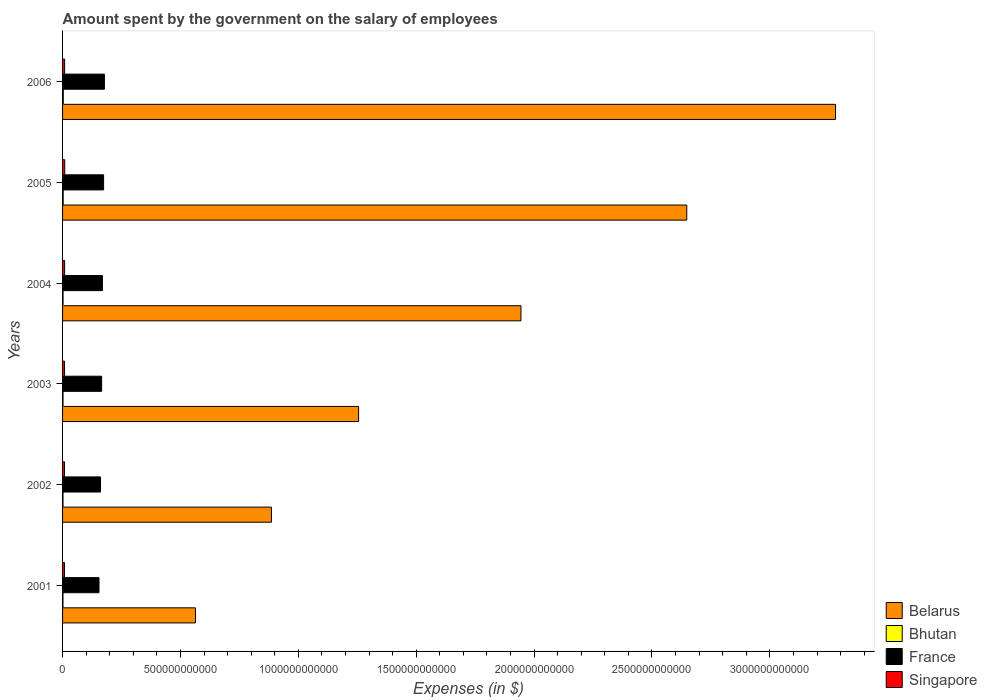How many different coloured bars are there?
Your response must be concise. 4. How many groups of bars are there?
Give a very brief answer. 6. Are the number of bars on each tick of the Y-axis equal?
Ensure brevity in your answer.  Yes. What is the label of the 3rd group of bars from the top?
Your response must be concise. 2004. In how many cases, is the number of bars for a given year not equal to the number of legend labels?
Offer a very short reply. 0. What is the amount spent on the salary of employees by the government in Bhutan in 2006?
Your answer should be compact. 3.09e+09. Across all years, what is the maximum amount spent on the salary of employees by the government in France?
Provide a short and direct response. 1.78e+11. Across all years, what is the minimum amount spent on the salary of employees by the government in Singapore?
Your response must be concise. 8.00e+09. In which year was the amount spent on the salary of employees by the government in France maximum?
Offer a terse response. 2006. What is the total amount spent on the salary of employees by the government in Singapore in the graph?
Offer a terse response. 5.11e+1. What is the difference between the amount spent on the salary of employees by the government in Belarus in 2002 and that in 2005?
Ensure brevity in your answer.  -1.76e+12. What is the difference between the amount spent on the salary of employees by the government in Belarus in 2004 and the amount spent on the salary of employees by the government in Bhutan in 2006?
Give a very brief answer. 1.94e+12. What is the average amount spent on the salary of employees by the government in Belarus per year?
Offer a very short reply. 1.76e+12. In the year 2003, what is the difference between the amount spent on the salary of employees by the government in Bhutan and amount spent on the salary of employees by the government in Singapore?
Your answer should be compact. -6.36e+09. In how many years, is the amount spent on the salary of employees by the government in Belarus greater than 800000000000 $?
Ensure brevity in your answer.  5. What is the ratio of the amount spent on the salary of employees by the government in France in 2004 to that in 2006?
Offer a very short reply. 0.95. Is the amount spent on the salary of employees by the government in France in 2003 less than that in 2004?
Offer a terse response. Yes. What is the difference between the highest and the second highest amount spent on the salary of employees by the government in Singapore?
Offer a terse response. 3.91e+08. What is the difference between the highest and the lowest amount spent on the salary of employees by the government in Bhutan?
Your answer should be very brief. 1.37e+09. In how many years, is the amount spent on the salary of employees by the government in Belarus greater than the average amount spent on the salary of employees by the government in Belarus taken over all years?
Your response must be concise. 3. Is the sum of the amount spent on the salary of employees by the government in France in 2002 and 2006 greater than the maximum amount spent on the salary of employees by the government in Bhutan across all years?
Provide a succinct answer. Yes. Is it the case that in every year, the sum of the amount spent on the salary of employees by the government in Belarus and amount spent on the salary of employees by the government in France is greater than the sum of amount spent on the salary of employees by the government in Bhutan and amount spent on the salary of employees by the government in Singapore?
Offer a very short reply. Yes. What does the 3rd bar from the top in 2003 represents?
Make the answer very short. Bhutan. What does the 1st bar from the bottom in 2002 represents?
Offer a very short reply. Belarus. Is it the case that in every year, the sum of the amount spent on the salary of employees by the government in Belarus and amount spent on the salary of employees by the government in France is greater than the amount spent on the salary of employees by the government in Singapore?
Your answer should be compact. Yes. How many bars are there?
Ensure brevity in your answer.  24. Are all the bars in the graph horizontal?
Make the answer very short. Yes. What is the difference between two consecutive major ticks on the X-axis?
Offer a very short reply. 5.00e+11. Does the graph contain any zero values?
Your response must be concise. No. What is the title of the graph?
Keep it short and to the point. Amount spent by the government on the salary of employees. Does "East Asia (developing only)" appear as one of the legend labels in the graph?
Give a very brief answer. No. What is the label or title of the X-axis?
Offer a very short reply. Expenses (in $). What is the label or title of the Y-axis?
Ensure brevity in your answer.  Years. What is the Expenses (in $) of Belarus in 2001?
Offer a terse response. 5.64e+11. What is the Expenses (in $) in Bhutan in 2001?
Provide a succinct answer. 1.72e+09. What is the Expenses (in $) of France in 2001?
Ensure brevity in your answer.  1.55e+11. What is the Expenses (in $) of Singapore in 2001?
Your answer should be compact. 8.00e+09. What is the Expenses (in $) of Belarus in 2002?
Your answer should be very brief. 8.86e+11. What is the Expenses (in $) in Bhutan in 2002?
Keep it short and to the point. 1.90e+09. What is the Expenses (in $) in France in 2002?
Keep it short and to the point. 1.61e+11. What is the Expenses (in $) in Singapore in 2002?
Provide a succinct answer. 8.28e+09. What is the Expenses (in $) in Belarus in 2003?
Provide a short and direct response. 1.26e+12. What is the Expenses (in $) in Bhutan in 2003?
Keep it short and to the point. 1.95e+09. What is the Expenses (in $) in France in 2003?
Ensure brevity in your answer.  1.66e+11. What is the Expenses (in $) of Singapore in 2003?
Your answer should be very brief. 8.31e+09. What is the Expenses (in $) of Belarus in 2004?
Give a very brief answer. 1.94e+12. What is the Expenses (in $) in Bhutan in 2004?
Provide a succinct answer. 2.09e+09. What is the Expenses (in $) in France in 2004?
Offer a very short reply. 1.69e+11. What is the Expenses (in $) in Singapore in 2004?
Provide a short and direct response. 8.71e+09. What is the Expenses (in $) of Belarus in 2005?
Provide a short and direct response. 2.65e+12. What is the Expenses (in $) of Bhutan in 2005?
Your answer should be compact. 2.65e+09. What is the Expenses (in $) in France in 2005?
Your response must be concise. 1.74e+11. What is the Expenses (in $) of Singapore in 2005?
Provide a short and direct response. 9.11e+09. What is the Expenses (in $) of Belarus in 2006?
Offer a terse response. 3.28e+12. What is the Expenses (in $) in Bhutan in 2006?
Your response must be concise. 3.09e+09. What is the Expenses (in $) in France in 2006?
Your answer should be very brief. 1.78e+11. What is the Expenses (in $) in Singapore in 2006?
Give a very brief answer. 8.72e+09. Across all years, what is the maximum Expenses (in $) in Belarus?
Your answer should be very brief. 3.28e+12. Across all years, what is the maximum Expenses (in $) in Bhutan?
Keep it short and to the point. 3.09e+09. Across all years, what is the maximum Expenses (in $) of France?
Keep it short and to the point. 1.78e+11. Across all years, what is the maximum Expenses (in $) of Singapore?
Your answer should be very brief. 9.11e+09. Across all years, what is the minimum Expenses (in $) of Belarus?
Your response must be concise. 5.64e+11. Across all years, what is the minimum Expenses (in $) in Bhutan?
Your response must be concise. 1.72e+09. Across all years, what is the minimum Expenses (in $) of France?
Offer a very short reply. 1.55e+11. Across all years, what is the minimum Expenses (in $) of Singapore?
Provide a succinct answer. 8.00e+09. What is the total Expenses (in $) of Belarus in the graph?
Make the answer very short. 1.06e+13. What is the total Expenses (in $) of Bhutan in the graph?
Make the answer very short. 1.34e+1. What is the total Expenses (in $) in France in the graph?
Give a very brief answer. 1.00e+12. What is the total Expenses (in $) of Singapore in the graph?
Provide a succinct answer. 5.11e+1. What is the difference between the Expenses (in $) in Belarus in 2001 and that in 2002?
Provide a short and direct response. -3.22e+11. What is the difference between the Expenses (in $) in Bhutan in 2001 and that in 2002?
Your response must be concise. -1.74e+08. What is the difference between the Expenses (in $) in France in 2001 and that in 2002?
Your answer should be compact. -6.46e+09. What is the difference between the Expenses (in $) in Singapore in 2001 and that in 2002?
Your answer should be very brief. -2.80e+08. What is the difference between the Expenses (in $) of Belarus in 2001 and that in 2003?
Keep it short and to the point. -6.92e+11. What is the difference between the Expenses (in $) of Bhutan in 2001 and that in 2003?
Your response must be concise. -2.24e+08. What is the difference between the Expenses (in $) in France in 2001 and that in 2003?
Your answer should be compact. -1.11e+1. What is the difference between the Expenses (in $) in Singapore in 2001 and that in 2003?
Keep it short and to the point. -3.03e+08. What is the difference between the Expenses (in $) in Belarus in 2001 and that in 2004?
Your answer should be very brief. -1.38e+12. What is the difference between the Expenses (in $) in Bhutan in 2001 and that in 2004?
Give a very brief answer. -3.64e+08. What is the difference between the Expenses (in $) of France in 2001 and that in 2004?
Your answer should be compact. -1.45e+1. What is the difference between the Expenses (in $) of Singapore in 2001 and that in 2004?
Offer a terse response. -7.03e+08. What is the difference between the Expenses (in $) in Belarus in 2001 and that in 2005?
Keep it short and to the point. -2.08e+12. What is the difference between the Expenses (in $) of Bhutan in 2001 and that in 2005?
Offer a terse response. -9.29e+08. What is the difference between the Expenses (in $) in France in 2001 and that in 2005?
Ensure brevity in your answer.  -1.95e+1. What is the difference between the Expenses (in $) of Singapore in 2001 and that in 2005?
Offer a very short reply. -1.11e+09. What is the difference between the Expenses (in $) in Belarus in 2001 and that in 2006?
Your response must be concise. -2.72e+12. What is the difference between the Expenses (in $) in Bhutan in 2001 and that in 2006?
Provide a succinct answer. -1.37e+09. What is the difference between the Expenses (in $) of France in 2001 and that in 2006?
Your answer should be compact. -2.30e+1. What is the difference between the Expenses (in $) of Singapore in 2001 and that in 2006?
Provide a short and direct response. -7.16e+08. What is the difference between the Expenses (in $) of Belarus in 2002 and that in 2003?
Keep it short and to the point. -3.70e+11. What is the difference between the Expenses (in $) in Bhutan in 2002 and that in 2003?
Offer a terse response. -4.99e+07. What is the difference between the Expenses (in $) of France in 2002 and that in 2003?
Keep it short and to the point. -4.66e+09. What is the difference between the Expenses (in $) in Singapore in 2002 and that in 2003?
Your answer should be compact. -2.30e+07. What is the difference between the Expenses (in $) of Belarus in 2002 and that in 2004?
Offer a terse response. -1.06e+12. What is the difference between the Expenses (in $) in Bhutan in 2002 and that in 2004?
Your answer should be very brief. -1.90e+08. What is the difference between the Expenses (in $) in France in 2002 and that in 2004?
Keep it short and to the point. -8.00e+09. What is the difference between the Expenses (in $) in Singapore in 2002 and that in 2004?
Your answer should be very brief. -4.23e+08. What is the difference between the Expenses (in $) of Belarus in 2002 and that in 2005?
Ensure brevity in your answer.  -1.76e+12. What is the difference between the Expenses (in $) in Bhutan in 2002 and that in 2005?
Offer a very short reply. -7.55e+08. What is the difference between the Expenses (in $) of France in 2002 and that in 2005?
Offer a very short reply. -1.31e+1. What is the difference between the Expenses (in $) of Singapore in 2002 and that in 2005?
Your answer should be compact. -8.27e+08. What is the difference between the Expenses (in $) of Belarus in 2002 and that in 2006?
Make the answer very short. -2.39e+12. What is the difference between the Expenses (in $) in Bhutan in 2002 and that in 2006?
Your response must be concise. -1.20e+09. What is the difference between the Expenses (in $) of France in 2002 and that in 2006?
Keep it short and to the point. -1.65e+1. What is the difference between the Expenses (in $) of Singapore in 2002 and that in 2006?
Your answer should be compact. -4.36e+08. What is the difference between the Expenses (in $) of Belarus in 2003 and that in 2004?
Your answer should be compact. -6.89e+11. What is the difference between the Expenses (in $) of Bhutan in 2003 and that in 2004?
Offer a very short reply. -1.40e+08. What is the difference between the Expenses (in $) in France in 2003 and that in 2004?
Provide a succinct answer. -3.34e+09. What is the difference between the Expenses (in $) in Singapore in 2003 and that in 2004?
Make the answer very short. -4.00e+08. What is the difference between the Expenses (in $) of Belarus in 2003 and that in 2005?
Provide a succinct answer. -1.39e+12. What is the difference between the Expenses (in $) of Bhutan in 2003 and that in 2005?
Make the answer very short. -7.05e+08. What is the difference between the Expenses (in $) of France in 2003 and that in 2005?
Give a very brief answer. -8.40e+09. What is the difference between the Expenses (in $) in Singapore in 2003 and that in 2005?
Your answer should be very brief. -8.04e+08. What is the difference between the Expenses (in $) of Belarus in 2003 and that in 2006?
Make the answer very short. -2.02e+12. What is the difference between the Expenses (in $) of Bhutan in 2003 and that in 2006?
Provide a succinct answer. -1.15e+09. What is the difference between the Expenses (in $) in France in 2003 and that in 2006?
Your answer should be compact. -1.19e+1. What is the difference between the Expenses (in $) of Singapore in 2003 and that in 2006?
Provide a short and direct response. -4.13e+08. What is the difference between the Expenses (in $) in Belarus in 2004 and that in 2005?
Your answer should be very brief. -7.03e+11. What is the difference between the Expenses (in $) in Bhutan in 2004 and that in 2005?
Provide a succinct answer. -5.66e+08. What is the difference between the Expenses (in $) of France in 2004 and that in 2005?
Your answer should be compact. -5.05e+09. What is the difference between the Expenses (in $) of Singapore in 2004 and that in 2005?
Ensure brevity in your answer.  -4.04e+08. What is the difference between the Expenses (in $) of Belarus in 2004 and that in 2006?
Give a very brief answer. -1.33e+12. What is the difference between the Expenses (in $) in Bhutan in 2004 and that in 2006?
Give a very brief answer. -1.01e+09. What is the difference between the Expenses (in $) in France in 2004 and that in 2006?
Your answer should be very brief. -8.55e+09. What is the difference between the Expenses (in $) of Singapore in 2004 and that in 2006?
Your response must be concise. -1.30e+07. What is the difference between the Expenses (in $) of Belarus in 2005 and that in 2006?
Provide a short and direct response. -6.31e+11. What is the difference between the Expenses (in $) in Bhutan in 2005 and that in 2006?
Offer a terse response. -4.40e+08. What is the difference between the Expenses (in $) of France in 2005 and that in 2006?
Your answer should be very brief. -3.49e+09. What is the difference between the Expenses (in $) in Singapore in 2005 and that in 2006?
Ensure brevity in your answer.  3.91e+08. What is the difference between the Expenses (in $) in Belarus in 2001 and the Expenses (in $) in Bhutan in 2002?
Ensure brevity in your answer.  5.62e+11. What is the difference between the Expenses (in $) in Belarus in 2001 and the Expenses (in $) in France in 2002?
Provide a succinct answer. 4.03e+11. What is the difference between the Expenses (in $) in Belarus in 2001 and the Expenses (in $) in Singapore in 2002?
Your answer should be very brief. 5.55e+11. What is the difference between the Expenses (in $) in Bhutan in 2001 and the Expenses (in $) in France in 2002?
Ensure brevity in your answer.  -1.59e+11. What is the difference between the Expenses (in $) in Bhutan in 2001 and the Expenses (in $) in Singapore in 2002?
Offer a terse response. -6.56e+09. What is the difference between the Expenses (in $) in France in 2001 and the Expenses (in $) in Singapore in 2002?
Give a very brief answer. 1.46e+11. What is the difference between the Expenses (in $) in Belarus in 2001 and the Expenses (in $) in Bhutan in 2003?
Offer a terse response. 5.62e+11. What is the difference between the Expenses (in $) of Belarus in 2001 and the Expenses (in $) of France in 2003?
Provide a short and direct response. 3.98e+11. What is the difference between the Expenses (in $) in Belarus in 2001 and the Expenses (in $) in Singapore in 2003?
Offer a terse response. 5.55e+11. What is the difference between the Expenses (in $) in Bhutan in 2001 and the Expenses (in $) in France in 2003?
Your response must be concise. -1.64e+11. What is the difference between the Expenses (in $) in Bhutan in 2001 and the Expenses (in $) in Singapore in 2003?
Your response must be concise. -6.58e+09. What is the difference between the Expenses (in $) of France in 2001 and the Expenses (in $) of Singapore in 2003?
Your answer should be compact. 1.46e+11. What is the difference between the Expenses (in $) in Belarus in 2001 and the Expenses (in $) in Bhutan in 2004?
Provide a succinct answer. 5.62e+11. What is the difference between the Expenses (in $) in Belarus in 2001 and the Expenses (in $) in France in 2004?
Give a very brief answer. 3.95e+11. What is the difference between the Expenses (in $) in Belarus in 2001 and the Expenses (in $) in Singapore in 2004?
Ensure brevity in your answer.  5.55e+11. What is the difference between the Expenses (in $) in Bhutan in 2001 and the Expenses (in $) in France in 2004?
Make the answer very short. -1.67e+11. What is the difference between the Expenses (in $) in Bhutan in 2001 and the Expenses (in $) in Singapore in 2004?
Provide a short and direct response. -6.98e+09. What is the difference between the Expenses (in $) in France in 2001 and the Expenses (in $) in Singapore in 2004?
Give a very brief answer. 1.46e+11. What is the difference between the Expenses (in $) of Belarus in 2001 and the Expenses (in $) of Bhutan in 2005?
Your response must be concise. 5.61e+11. What is the difference between the Expenses (in $) of Belarus in 2001 and the Expenses (in $) of France in 2005?
Provide a short and direct response. 3.90e+11. What is the difference between the Expenses (in $) in Belarus in 2001 and the Expenses (in $) in Singapore in 2005?
Make the answer very short. 5.55e+11. What is the difference between the Expenses (in $) in Bhutan in 2001 and the Expenses (in $) in France in 2005?
Provide a short and direct response. -1.72e+11. What is the difference between the Expenses (in $) in Bhutan in 2001 and the Expenses (in $) in Singapore in 2005?
Provide a short and direct response. -7.39e+09. What is the difference between the Expenses (in $) of France in 2001 and the Expenses (in $) of Singapore in 2005?
Your answer should be compact. 1.45e+11. What is the difference between the Expenses (in $) of Belarus in 2001 and the Expenses (in $) of Bhutan in 2006?
Give a very brief answer. 5.61e+11. What is the difference between the Expenses (in $) in Belarus in 2001 and the Expenses (in $) in France in 2006?
Provide a short and direct response. 3.86e+11. What is the difference between the Expenses (in $) of Belarus in 2001 and the Expenses (in $) of Singapore in 2006?
Give a very brief answer. 5.55e+11. What is the difference between the Expenses (in $) of Bhutan in 2001 and the Expenses (in $) of France in 2006?
Provide a short and direct response. -1.76e+11. What is the difference between the Expenses (in $) of Bhutan in 2001 and the Expenses (in $) of Singapore in 2006?
Your answer should be compact. -7.00e+09. What is the difference between the Expenses (in $) of France in 2001 and the Expenses (in $) of Singapore in 2006?
Ensure brevity in your answer.  1.46e+11. What is the difference between the Expenses (in $) of Belarus in 2002 and the Expenses (in $) of Bhutan in 2003?
Your response must be concise. 8.84e+11. What is the difference between the Expenses (in $) in Belarus in 2002 and the Expenses (in $) in France in 2003?
Offer a terse response. 7.20e+11. What is the difference between the Expenses (in $) in Belarus in 2002 and the Expenses (in $) in Singapore in 2003?
Your answer should be very brief. 8.78e+11. What is the difference between the Expenses (in $) in Bhutan in 2002 and the Expenses (in $) in France in 2003?
Offer a very short reply. -1.64e+11. What is the difference between the Expenses (in $) in Bhutan in 2002 and the Expenses (in $) in Singapore in 2003?
Provide a succinct answer. -6.41e+09. What is the difference between the Expenses (in $) of France in 2002 and the Expenses (in $) of Singapore in 2003?
Offer a very short reply. 1.53e+11. What is the difference between the Expenses (in $) of Belarus in 2002 and the Expenses (in $) of Bhutan in 2004?
Offer a terse response. 8.84e+11. What is the difference between the Expenses (in $) in Belarus in 2002 and the Expenses (in $) in France in 2004?
Provide a succinct answer. 7.17e+11. What is the difference between the Expenses (in $) in Belarus in 2002 and the Expenses (in $) in Singapore in 2004?
Ensure brevity in your answer.  8.77e+11. What is the difference between the Expenses (in $) in Bhutan in 2002 and the Expenses (in $) in France in 2004?
Your answer should be very brief. -1.67e+11. What is the difference between the Expenses (in $) in Bhutan in 2002 and the Expenses (in $) in Singapore in 2004?
Ensure brevity in your answer.  -6.81e+09. What is the difference between the Expenses (in $) of France in 2002 and the Expenses (in $) of Singapore in 2004?
Provide a succinct answer. 1.52e+11. What is the difference between the Expenses (in $) in Belarus in 2002 and the Expenses (in $) in Bhutan in 2005?
Give a very brief answer. 8.83e+11. What is the difference between the Expenses (in $) of Belarus in 2002 and the Expenses (in $) of France in 2005?
Your answer should be very brief. 7.12e+11. What is the difference between the Expenses (in $) in Belarus in 2002 and the Expenses (in $) in Singapore in 2005?
Provide a succinct answer. 8.77e+11. What is the difference between the Expenses (in $) in Bhutan in 2002 and the Expenses (in $) in France in 2005?
Keep it short and to the point. -1.72e+11. What is the difference between the Expenses (in $) of Bhutan in 2002 and the Expenses (in $) of Singapore in 2005?
Offer a very short reply. -7.21e+09. What is the difference between the Expenses (in $) of France in 2002 and the Expenses (in $) of Singapore in 2005?
Give a very brief answer. 1.52e+11. What is the difference between the Expenses (in $) of Belarus in 2002 and the Expenses (in $) of Bhutan in 2006?
Provide a short and direct response. 8.83e+11. What is the difference between the Expenses (in $) of Belarus in 2002 and the Expenses (in $) of France in 2006?
Your answer should be compact. 7.08e+11. What is the difference between the Expenses (in $) in Belarus in 2002 and the Expenses (in $) in Singapore in 2006?
Offer a terse response. 8.77e+11. What is the difference between the Expenses (in $) in Bhutan in 2002 and the Expenses (in $) in France in 2006?
Provide a short and direct response. -1.76e+11. What is the difference between the Expenses (in $) of Bhutan in 2002 and the Expenses (in $) of Singapore in 2006?
Keep it short and to the point. -6.82e+09. What is the difference between the Expenses (in $) of France in 2002 and the Expenses (in $) of Singapore in 2006?
Offer a terse response. 1.52e+11. What is the difference between the Expenses (in $) in Belarus in 2003 and the Expenses (in $) in Bhutan in 2004?
Provide a short and direct response. 1.25e+12. What is the difference between the Expenses (in $) of Belarus in 2003 and the Expenses (in $) of France in 2004?
Keep it short and to the point. 1.09e+12. What is the difference between the Expenses (in $) in Belarus in 2003 and the Expenses (in $) in Singapore in 2004?
Provide a short and direct response. 1.25e+12. What is the difference between the Expenses (in $) in Bhutan in 2003 and the Expenses (in $) in France in 2004?
Provide a short and direct response. -1.67e+11. What is the difference between the Expenses (in $) in Bhutan in 2003 and the Expenses (in $) in Singapore in 2004?
Give a very brief answer. -6.76e+09. What is the difference between the Expenses (in $) in France in 2003 and the Expenses (in $) in Singapore in 2004?
Provide a short and direct response. 1.57e+11. What is the difference between the Expenses (in $) in Belarus in 2003 and the Expenses (in $) in Bhutan in 2005?
Provide a short and direct response. 1.25e+12. What is the difference between the Expenses (in $) in Belarus in 2003 and the Expenses (in $) in France in 2005?
Your answer should be compact. 1.08e+12. What is the difference between the Expenses (in $) of Belarus in 2003 and the Expenses (in $) of Singapore in 2005?
Provide a succinct answer. 1.25e+12. What is the difference between the Expenses (in $) in Bhutan in 2003 and the Expenses (in $) in France in 2005?
Give a very brief answer. -1.72e+11. What is the difference between the Expenses (in $) of Bhutan in 2003 and the Expenses (in $) of Singapore in 2005?
Keep it short and to the point. -7.16e+09. What is the difference between the Expenses (in $) of France in 2003 and the Expenses (in $) of Singapore in 2005?
Provide a succinct answer. 1.57e+11. What is the difference between the Expenses (in $) of Belarus in 2003 and the Expenses (in $) of Bhutan in 2006?
Offer a very short reply. 1.25e+12. What is the difference between the Expenses (in $) in Belarus in 2003 and the Expenses (in $) in France in 2006?
Offer a terse response. 1.08e+12. What is the difference between the Expenses (in $) of Belarus in 2003 and the Expenses (in $) of Singapore in 2006?
Provide a short and direct response. 1.25e+12. What is the difference between the Expenses (in $) in Bhutan in 2003 and the Expenses (in $) in France in 2006?
Your answer should be compact. -1.76e+11. What is the difference between the Expenses (in $) of Bhutan in 2003 and the Expenses (in $) of Singapore in 2006?
Provide a succinct answer. -6.77e+09. What is the difference between the Expenses (in $) of France in 2003 and the Expenses (in $) of Singapore in 2006?
Your answer should be very brief. 1.57e+11. What is the difference between the Expenses (in $) of Belarus in 2004 and the Expenses (in $) of Bhutan in 2005?
Make the answer very short. 1.94e+12. What is the difference between the Expenses (in $) in Belarus in 2004 and the Expenses (in $) in France in 2005?
Your answer should be compact. 1.77e+12. What is the difference between the Expenses (in $) in Belarus in 2004 and the Expenses (in $) in Singapore in 2005?
Your response must be concise. 1.94e+12. What is the difference between the Expenses (in $) in Bhutan in 2004 and the Expenses (in $) in France in 2005?
Provide a short and direct response. -1.72e+11. What is the difference between the Expenses (in $) in Bhutan in 2004 and the Expenses (in $) in Singapore in 2005?
Your answer should be compact. -7.02e+09. What is the difference between the Expenses (in $) of France in 2004 and the Expenses (in $) of Singapore in 2005?
Make the answer very short. 1.60e+11. What is the difference between the Expenses (in $) in Belarus in 2004 and the Expenses (in $) in Bhutan in 2006?
Provide a short and direct response. 1.94e+12. What is the difference between the Expenses (in $) of Belarus in 2004 and the Expenses (in $) of France in 2006?
Make the answer very short. 1.77e+12. What is the difference between the Expenses (in $) in Belarus in 2004 and the Expenses (in $) in Singapore in 2006?
Offer a terse response. 1.94e+12. What is the difference between the Expenses (in $) in Bhutan in 2004 and the Expenses (in $) in France in 2006?
Ensure brevity in your answer.  -1.75e+11. What is the difference between the Expenses (in $) of Bhutan in 2004 and the Expenses (in $) of Singapore in 2006?
Keep it short and to the point. -6.63e+09. What is the difference between the Expenses (in $) in France in 2004 and the Expenses (in $) in Singapore in 2006?
Provide a succinct answer. 1.60e+11. What is the difference between the Expenses (in $) of Belarus in 2005 and the Expenses (in $) of Bhutan in 2006?
Offer a very short reply. 2.64e+12. What is the difference between the Expenses (in $) of Belarus in 2005 and the Expenses (in $) of France in 2006?
Your answer should be very brief. 2.47e+12. What is the difference between the Expenses (in $) in Belarus in 2005 and the Expenses (in $) in Singapore in 2006?
Provide a succinct answer. 2.64e+12. What is the difference between the Expenses (in $) of Bhutan in 2005 and the Expenses (in $) of France in 2006?
Ensure brevity in your answer.  -1.75e+11. What is the difference between the Expenses (in $) of Bhutan in 2005 and the Expenses (in $) of Singapore in 2006?
Provide a succinct answer. -6.07e+09. What is the difference between the Expenses (in $) in France in 2005 and the Expenses (in $) in Singapore in 2006?
Provide a succinct answer. 1.65e+11. What is the average Expenses (in $) of Belarus per year?
Your answer should be very brief. 1.76e+12. What is the average Expenses (in $) in Bhutan per year?
Offer a very short reply. 2.23e+09. What is the average Expenses (in $) of France per year?
Keep it short and to the point. 1.67e+11. What is the average Expenses (in $) in Singapore per year?
Give a very brief answer. 8.52e+09. In the year 2001, what is the difference between the Expenses (in $) of Belarus and Expenses (in $) of Bhutan?
Provide a succinct answer. 5.62e+11. In the year 2001, what is the difference between the Expenses (in $) of Belarus and Expenses (in $) of France?
Your answer should be compact. 4.09e+11. In the year 2001, what is the difference between the Expenses (in $) in Belarus and Expenses (in $) in Singapore?
Keep it short and to the point. 5.56e+11. In the year 2001, what is the difference between the Expenses (in $) in Bhutan and Expenses (in $) in France?
Ensure brevity in your answer.  -1.53e+11. In the year 2001, what is the difference between the Expenses (in $) in Bhutan and Expenses (in $) in Singapore?
Keep it short and to the point. -6.28e+09. In the year 2001, what is the difference between the Expenses (in $) in France and Expenses (in $) in Singapore?
Offer a terse response. 1.47e+11. In the year 2002, what is the difference between the Expenses (in $) of Belarus and Expenses (in $) of Bhutan?
Provide a succinct answer. 8.84e+11. In the year 2002, what is the difference between the Expenses (in $) of Belarus and Expenses (in $) of France?
Give a very brief answer. 7.25e+11. In the year 2002, what is the difference between the Expenses (in $) in Belarus and Expenses (in $) in Singapore?
Your response must be concise. 8.78e+11. In the year 2002, what is the difference between the Expenses (in $) in Bhutan and Expenses (in $) in France?
Your answer should be very brief. -1.59e+11. In the year 2002, what is the difference between the Expenses (in $) in Bhutan and Expenses (in $) in Singapore?
Keep it short and to the point. -6.39e+09. In the year 2002, what is the difference between the Expenses (in $) in France and Expenses (in $) in Singapore?
Make the answer very short. 1.53e+11. In the year 2003, what is the difference between the Expenses (in $) of Belarus and Expenses (in $) of Bhutan?
Your response must be concise. 1.25e+12. In the year 2003, what is the difference between the Expenses (in $) in Belarus and Expenses (in $) in France?
Ensure brevity in your answer.  1.09e+12. In the year 2003, what is the difference between the Expenses (in $) in Belarus and Expenses (in $) in Singapore?
Provide a succinct answer. 1.25e+12. In the year 2003, what is the difference between the Expenses (in $) in Bhutan and Expenses (in $) in France?
Your answer should be very brief. -1.64e+11. In the year 2003, what is the difference between the Expenses (in $) of Bhutan and Expenses (in $) of Singapore?
Keep it short and to the point. -6.36e+09. In the year 2003, what is the difference between the Expenses (in $) in France and Expenses (in $) in Singapore?
Ensure brevity in your answer.  1.57e+11. In the year 2004, what is the difference between the Expenses (in $) in Belarus and Expenses (in $) in Bhutan?
Make the answer very short. 1.94e+12. In the year 2004, what is the difference between the Expenses (in $) in Belarus and Expenses (in $) in France?
Your answer should be very brief. 1.78e+12. In the year 2004, what is the difference between the Expenses (in $) of Belarus and Expenses (in $) of Singapore?
Give a very brief answer. 1.94e+12. In the year 2004, what is the difference between the Expenses (in $) in Bhutan and Expenses (in $) in France?
Keep it short and to the point. -1.67e+11. In the year 2004, what is the difference between the Expenses (in $) of Bhutan and Expenses (in $) of Singapore?
Ensure brevity in your answer.  -6.62e+09. In the year 2004, what is the difference between the Expenses (in $) of France and Expenses (in $) of Singapore?
Keep it short and to the point. 1.60e+11. In the year 2005, what is the difference between the Expenses (in $) of Belarus and Expenses (in $) of Bhutan?
Provide a succinct answer. 2.64e+12. In the year 2005, what is the difference between the Expenses (in $) in Belarus and Expenses (in $) in France?
Your answer should be compact. 2.47e+12. In the year 2005, what is the difference between the Expenses (in $) of Belarus and Expenses (in $) of Singapore?
Make the answer very short. 2.64e+12. In the year 2005, what is the difference between the Expenses (in $) of Bhutan and Expenses (in $) of France?
Your answer should be very brief. -1.71e+11. In the year 2005, what is the difference between the Expenses (in $) in Bhutan and Expenses (in $) in Singapore?
Provide a short and direct response. -6.46e+09. In the year 2005, what is the difference between the Expenses (in $) of France and Expenses (in $) of Singapore?
Your response must be concise. 1.65e+11. In the year 2006, what is the difference between the Expenses (in $) of Belarus and Expenses (in $) of Bhutan?
Make the answer very short. 3.28e+12. In the year 2006, what is the difference between the Expenses (in $) of Belarus and Expenses (in $) of France?
Your answer should be very brief. 3.10e+12. In the year 2006, what is the difference between the Expenses (in $) in Belarus and Expenses (in $) in Singapore?
Offer a terse response. 3.27e+12. In the year 2006, what is the difference between the Expenses (in $) in Bhutan and Expenses (in $) in France?
Ensure brevity in your answer.  -1.74e+11. In the year 2006, what is the difference between the Expenses (in $) of Bhutan and Expenses (in $) of Singapore?
Provide a short and direct response. -5.63e+09. In the year 2006, what is the difference between the Expenses (in $) in France and Expenses (in $) in Singapore?
Your response must be concise. 1.69e+11. What is the ratio of the Expenses (in $) in Belarus in 2001 to that in 2002?
Your answer should be compact. 0.64. What is the ratio of the Expenses (in $) in Bhutan in 2001 to that in 2002?
Your response must be concise. 0.91. What is the ratio of the Expenses (in $) of France in 2001 to that in 2002?
Provide a short and direct response. 0.96. What is the ratio of the Expenses (in $) of Singapore in 2001 to that in 2002?
Provide a short and direct response. 0.97. What is the ratio of the Expenses (in $) in Belarus in 2001 to that in 2003?
Provide a short and direct response. 0.45. What is the ratio of the Expenses (in $) of Bhutan in 2001 to that in 2003?
Ensure brevity in your answer.  0.88. What is the ratio of the Expenses (in $) in France in 2001 to that in 2003?
Provide a succinct answer. 0.93. What is the ratio of the Expenses (in $) in Singapore in 2001 to that in 2003?
Ensure brevity in your answer.  0.96. What is the ratio of the Expenses (in $) of Belarus in 2001 to that in 2004?
Your response must be concise. 0.29. What is the ratio of the Expenses (in $) of Bhutan in 2001 to that in 2004?
Keep it short and to the point. 0.83. What is the ratio of the Expenses (in $) of France in 2001 to that in 2004?
Provide a short and direct response. 0.91. What is the ratio of the Expenses (in $) of Singapore in 2001 to that in 2004?
Keep it short and to the point. 0.92. What is the ratio of the Expenses (in $) of Belarus in 2001 to that in 2005?
Keep it short and to the point. 0.21. What is the ratio of the Expenses (in $) in Bhutan in 2001 to that in 2005?
Your answer should be compact. 0.65. What is the ratio of the Expenses (in $) of France in 2001 to that in 2005?
Keep it short and to the point. 0.89. What is the ratio of the Expenses (in $) in Singapore in 2001 to that in 2005?
Keep it short and to the point. 0.88. What is the ratio of the Expenses (in $) of Belarus in 2001 to that in 2006?
Provide a succinct answer. 0.17. What is the ratio of the Expenses (in $) of Bhutan in 2001 to that in 2006?
Your response must be concise. 0.56. What is the ratio of the Expenses (in $) of France in 2001 to that in 2006?
Give a very brief answer. 0.87. What is the ratio of the Expenses (in $) in Singapore in 2001 to that in 2006?
Ensure brevity in your answer.  0.92. What is the ratio of the Expenses (in $) of Belarus in 2002 to that in 2003?
Your answer should be compact. 0.71. What is the ratio of the Expenses (in $) of Bhutan in 2002 to that in 2003?
Your answer should be very brief. 0.97. What is the ratio of the Expenses (in $) of France in 2002 to that in 2003?
Make the answer very short. 0.97. What is the ratio of the Expenses (in $) of Singapore in 2002 to that in 2003?
Give a very brief answer. 1. What is the ratio of the Expenses (in $) of Belarus in 2002 to that in 2004?
Offer a terse response. 0.46. What is the ratio of the Expenses (in $) of France in 2002 to that in 2004?
Offer a terse response. 0.95. What is the ratio of the Expenses (in $) in Singapore in 2002 to that in 2004?
Ensure brevity in your answer.  0.95. What is the ratio of the Expenses (in $) of Belarus in 2002 to that in 2005?
Make the answer very short. 0.33. What is the ratio of the Expenses (in $) of Bhutan in 2002 to that in 2005?
Provide a short and direct response. 0.72. What is the ratio of the Expenses (in $) of France in 2002 to that in 2005?
Keep it short and to the point. 0.93. What is the ratio of the Expenses (in $) in Singapore in 2002 to that in 2005?
Your answer should be compact. 0.91. What is the ratio of the Expenses (in $) in Belarus in 2002 to that in 2006?
Provide a succinct answer. 0.27. What is the ratio of the Expenses (in $) of Bhutan in 2002 to that in 2006?
Make the answer very short. 0.61. What is the ratio of the Expenses (in $) of France in 2002 to that in 2006?
Your answer should be compact. 0.91. What is the ratio of the Expenses (in $) of Singapore in 2002 to that in 2006?
Give a very brief answer. 0.95. What is the ratio of the Expenses (in $) of Belarus in 2003 to that in 2004?
Provide a short and direct response. 0.65. What is the ratio of the Expenses (in $) in Bhutan in 2003 to that in 2004?
Give a very brief answer. 0.93. What is the ratio of the Expenses (in $) of France in 2003 to that in 2004?
Your answer should be compact. 0.98. What is the ratio of the Expenses (in $) in Singapore in 2003 to that in 2004?
Give a very brief answer. 0.95. What is the ratio of the Expenses (in $) of Belarus in 2003 to that in 2005?
Give a very brief answer. 0.47. What is the ratio of the Expenses (in $) in Bhutan in 2003 to that in 2005?
Provide a succinct answer. 0.73. What is the ratio of the Expenses (in $) in France in 2003 to that in 2005?
Your answer should be very brief. 0.95. What is the ratio of the Expenses (in $) of Singapore in 2003 to that in 2005?
Offer a very short reply. 0.91. What is the ratio of the Expenses (in $) of Belarus in 2003 to that in 2006?
Keep it short and to the point. 0.38. What is the ratio of the Expenses (in $) of Bhutan in 2003 to that in 2006?
Keep it short and to the point. 0.63. What is the ratio of the Expenses (in $) of France in 2003 to that in 2006?
Provide a succinct answer. 0.93. What is the ratio of the Expenses (in $) in Singapore in 2003 to that in 2006?
Your response must be concise. 0.95. What is the ratio of the Expenses (in $) in Belarus in 2004 to that in 2005?
Keep it short and to the point. 0.73. What is the ratio of the Expenses (in $) of Bhutan in 2004 to that in 2005?
Make the answer very short. 0.79. What is the ratio of the Expenses (in $) in France in 2004 to that in 2005?
Make the answer very short. 0.97. What is the ratio of the Expenses (in $) of Singapore in 2004 to that in 2005?
Provide a succinct answer. 0.96. What is the ratio of the Expenses (in $) of Belarus in 2004 to that in 2006?
Offer a very short reply. 0.59. What is the ratio of the Expenses (in $) in Bhutan in 2004 to that in 2006?
Your response must be concise. 0.67. What is the ratio of the Expenses (in $) of France in 2004 to that in 2006?
Make the answer very short. 0.95. What is the ratio of the Expenses (in $) in Singapore in 2004 to that in 2006?
Give a very brief answer. 1. What is the ratio of the Expenses (in $) of Belarus in 2005 to that in 2006?
Keep it short and to the point. 0.81. What is the ratio of the Expenses (in $) in Bhutan in 2005 to that in 2006?
Keep it short and to the point. 0.86. What is the ratio of the Expenses (in $) of France in 2005 to that in 2006?
Provide a succinct answer. 0.98. What is the ratio of the Expenses (in $) in Singapore in 2005 to that in 2006?
Your response must be concise. 1.04. What is the difference between the highest and the second highest Expenses (in $) in Belarus?
Offer a terse response. 6.31e+11. What is the difference between the highest and the second highest Expenses (in $) of Bhutan?
Your answer should be very brief. 4.40e+08. What is the difference between the highest and the second highest Expenses (in $) of France?
Your answer should be very brief. 3.49e+09. What is the difference between the highest and the second highest Expenses (in $) in Singapore?
Offer a very short reply. 3.91e+08. What is the difference between the highest and the lowest Expenses (in $) of Belarus?
Offer a very short reply. 2.72e+12. What is the difference between the highest and the lowest Expenses (in $) in Bhutan?
Your answer should be compact. 1.37e+09. What is the difference between the highest and the lowest Expenses (in $) in France?
Give a very brief answer. 2.30e+1. What is the difference between the highest and the lowest Expenses (in $) of Singapore?
Offer a terse response. 1.11e+09. 